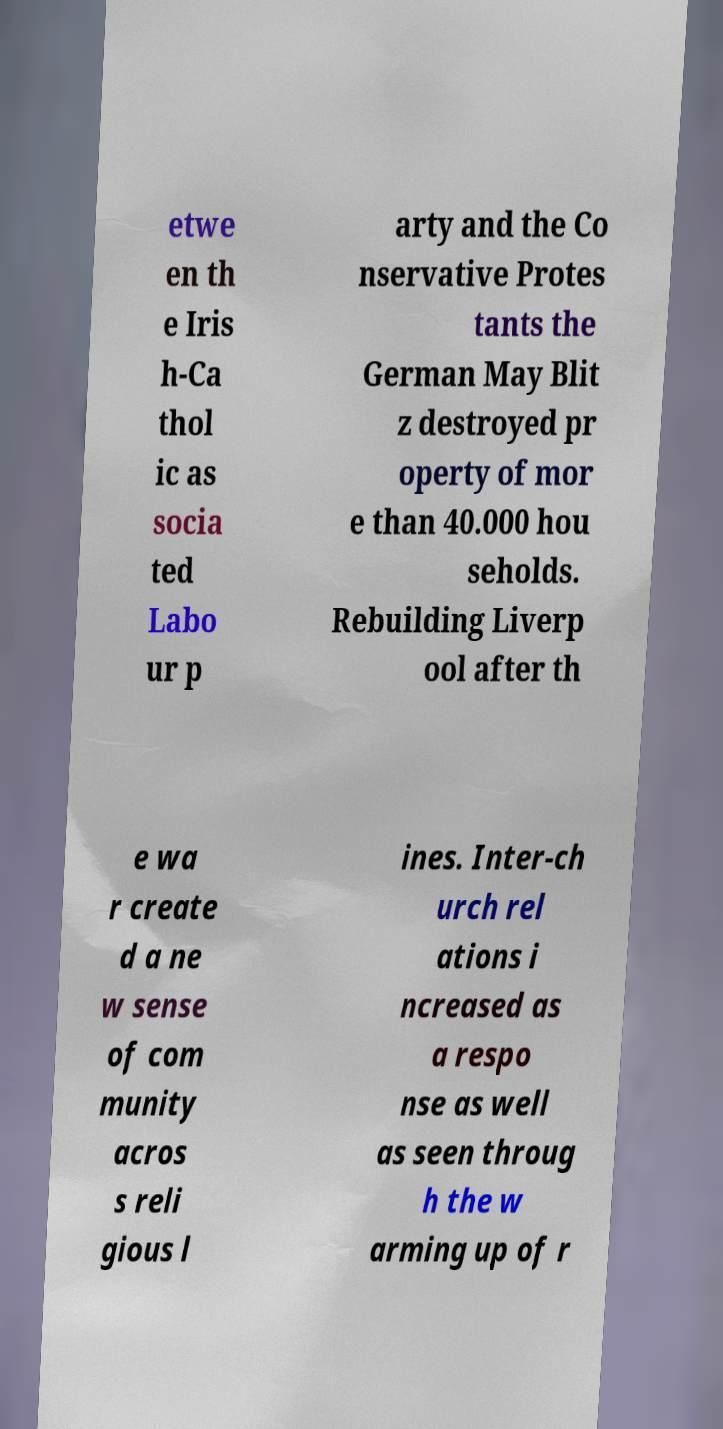Please identify and transcribe the text found in this image. etwe en th e Iris h-Ca thol ic as socia ted Labo ur p arty and the Co nservative Protes tants the German May Blit z destroyed pr operty of mor e than 40.000 hou seholds. Rebuilding Liverp ool after th e wa r create d a ne w sense of com munity acros s reli gious l ines. Inter-ch urch rel ations i ncreased as a respo nse as well as seen throug h the w arming up of r 